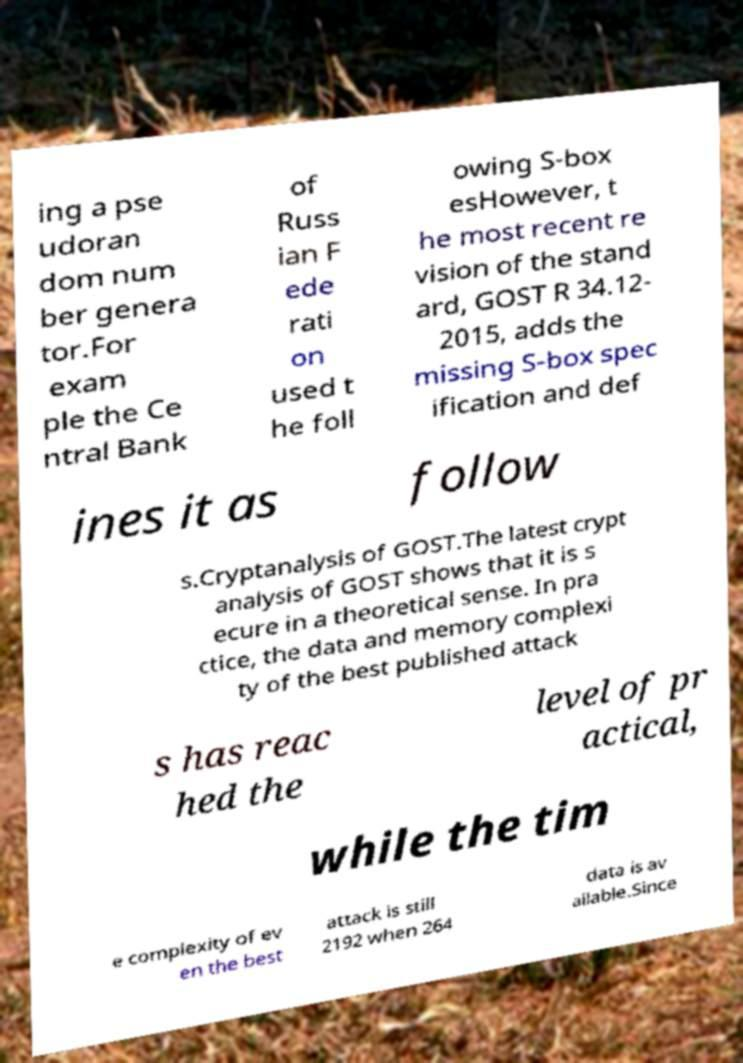Can you accurately transcribe the text from the provided image for me? ing a pse udoran dom num ber genera tor.For exam ple the Ce ntral Bank of Russ ian F ede rati on used t he foll owing S-box esHowever, t he most recent re vision of the stand ard, GOST R 34.12- 2015, adds the missing S-box spec ification and def ines it as follow s.Cryptanalysis of GOST.The latest crypt analysis of GOST shows that it is s ecure in a theoretical sense. In pra ctice, the data and memory complexi ty of the best published attack s has reac hed the level of pr actical, while the tim e complexity of ev en the best attack is still 2192 when 264 data is av ailable.Since 